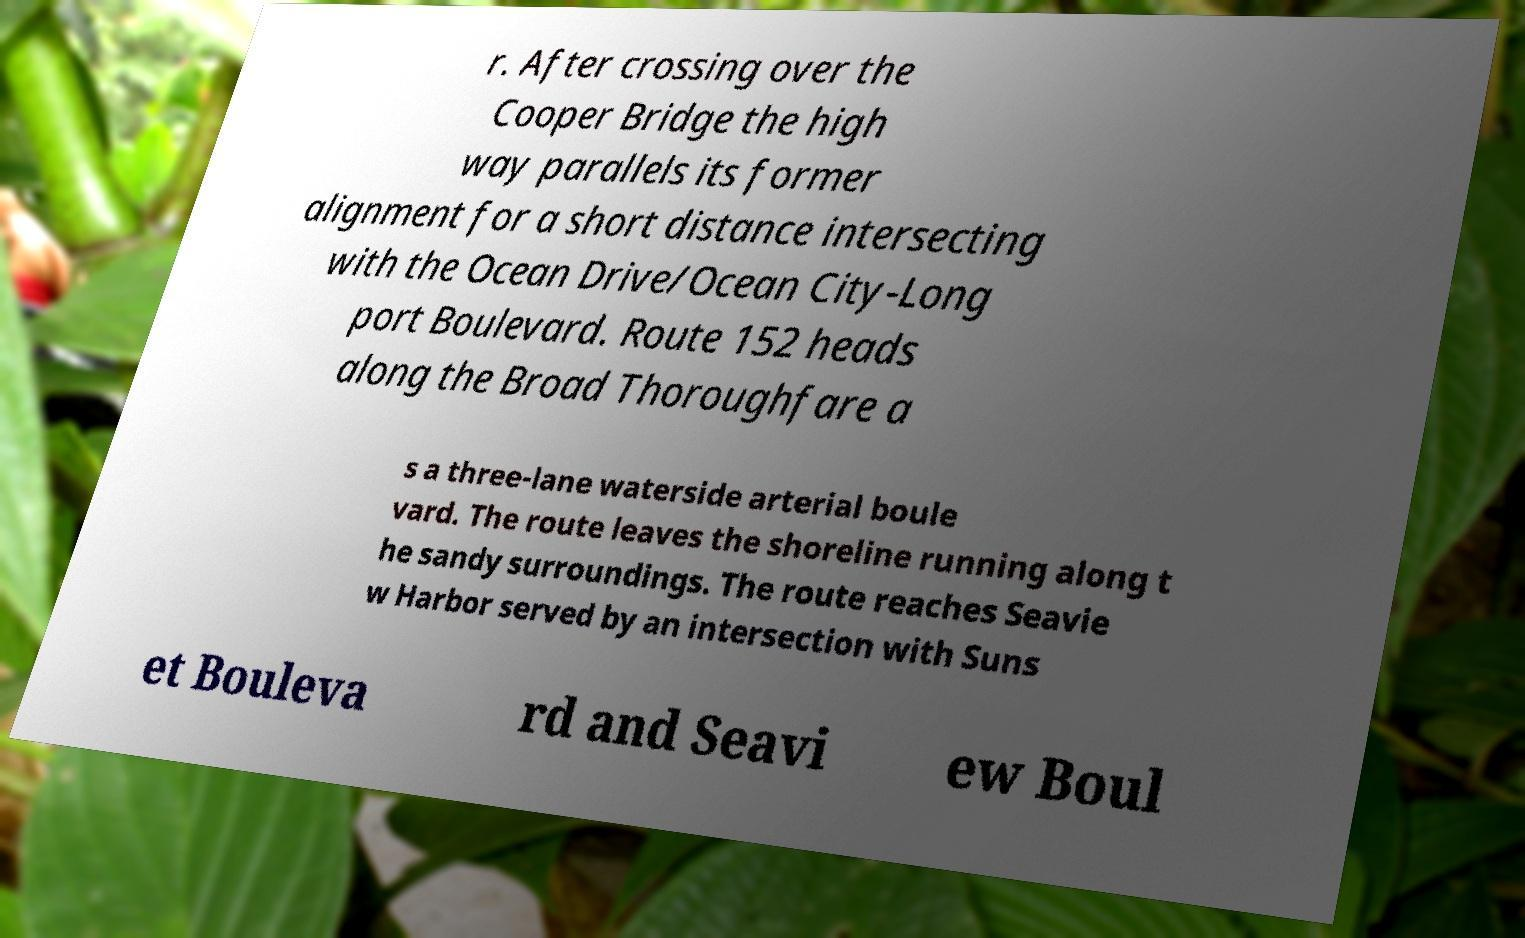Could you assist in decoding the text presented in this image and type it out clearly? r. After crossing over the Cooper Bridge the high way parallels its former alignment for a short distance intersecting with the Ocean Drive/Ocean City-Long port Boulevard. Route 152 heads along the Broad Thoroughfare a s a three-lane waterside arterial boule vard. The route leaves the shoreline running along t he sandy surroundings. The route reaches Seavie w Harbor served by an intersection with Suns et Bouleva rd and Seavi ew Boul 